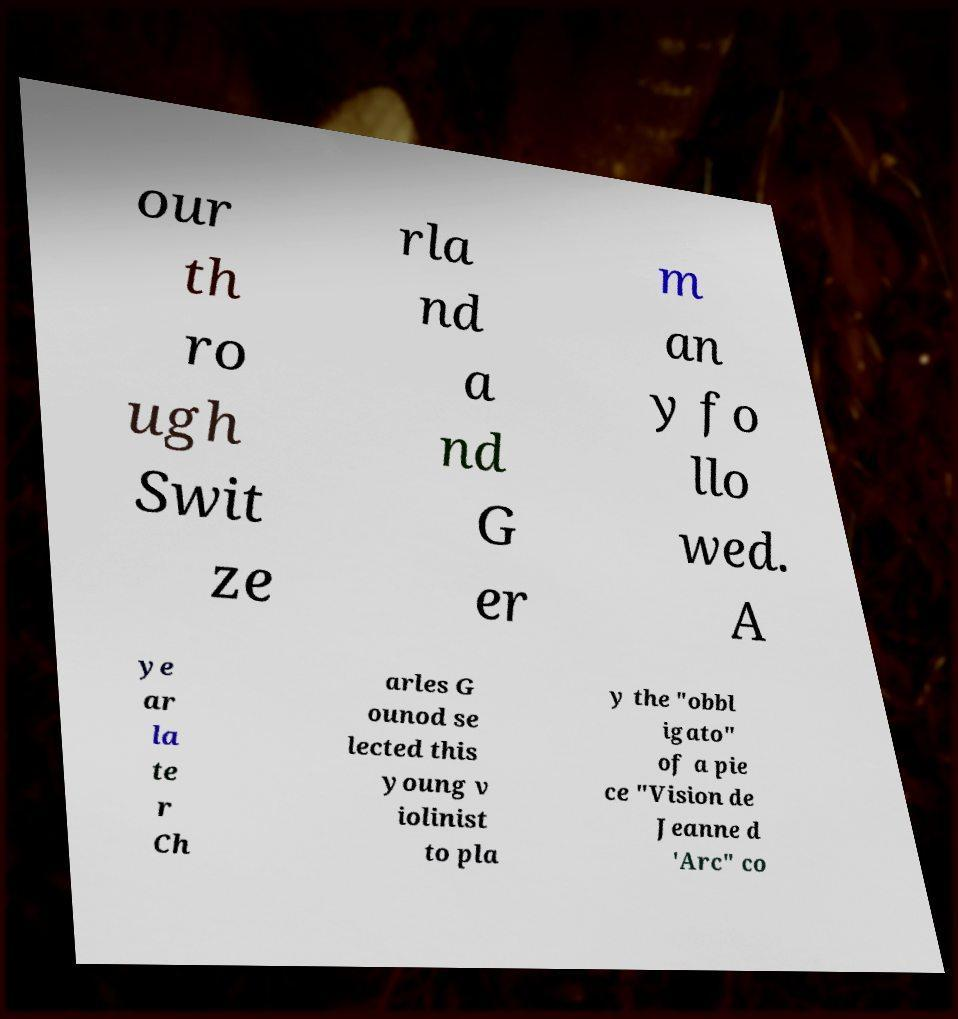I need the written content from this picture converted into text. Can you do that? our th ro ugh Swit ze rla nd a nd G er m an y fo llo wed. A ye ar la te r Ch arles G ounod se lected this young v iolinist to pla y the "obbl igato" of a pie ce "Vision de Jeanne d 'Arc" co 